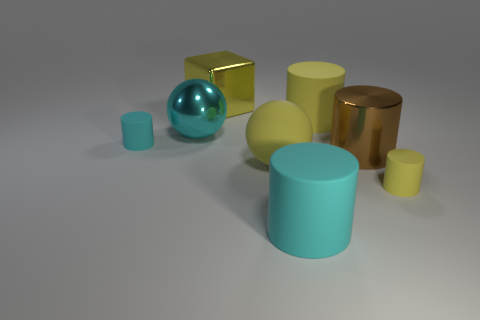Is the material of the tiny yellow cylinder the same as the large cyan object behind the small yellow thing?
Your answer should be very brief. No. There is a large cyan rubber object; is it the same shape as the tiny object on the right side of the large cyan metallic object?
Offer a very short reply. Yes. What is the size of the yellow thing that is behind the large brown shiny cylinder and in front of the cube?
Provide a succinct answer. Large. What is the shape of the large brown object?
Your response must be concise. Cylinder. There is a thing on the left side of the cyan metallic thing; is there a rubber object on the right side of it?
Offer a terse response. Yes. What number of large yellow spheres are left of the large sphere in front of the big cyan metallic object?
Your answer should be very brief. 0. What is the material of the yellow cylinder that is the same size as the yellow cube?
Ensure brevity in your answer.  Rubber. Do the rubber object to the left of the big cube and the small yellow matte thing have the same shape?
Give a very brief answer. Yes. Are there more matte spheres to the left of the brown shiny thing than yellow spheres that are to the left of the big cyan metal object?
Keep it short and to the point. Yes. What number of things have the same material as the yellow ball?
Your answer should be very brief. 4. 